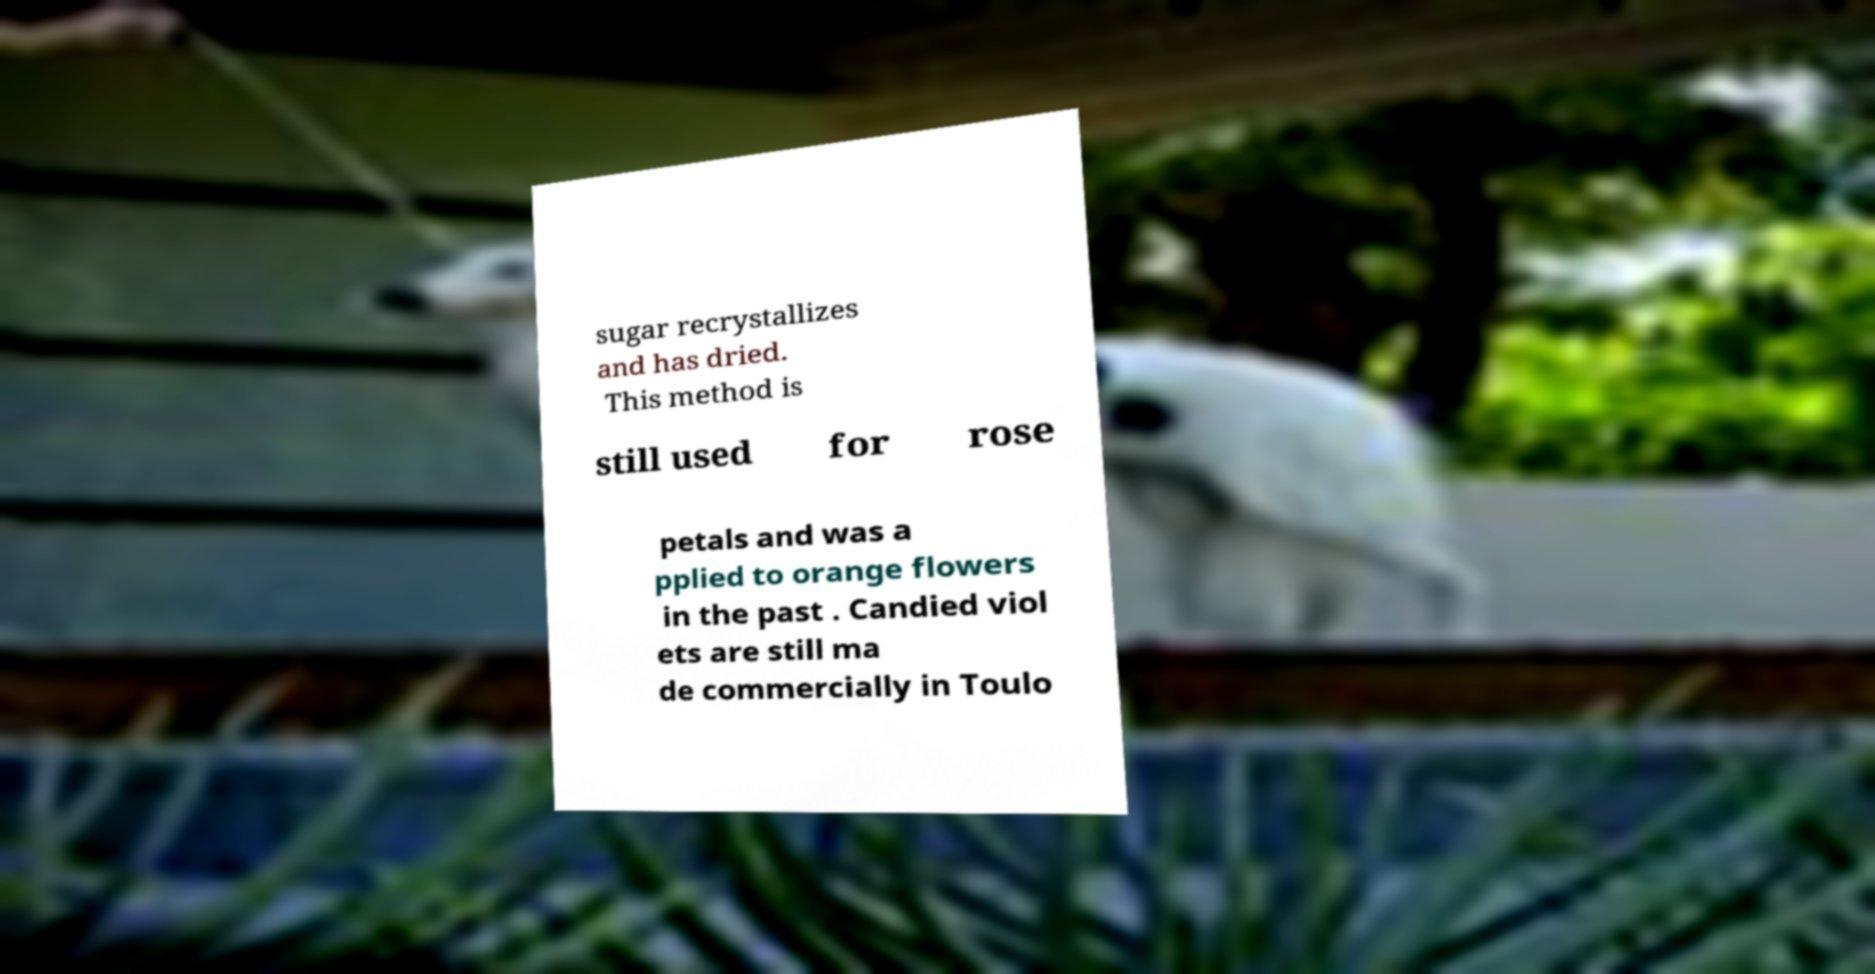Can you accurately transcribe the text from the provided image for me? sugar recrystallizes and has dried. This method is still used for rose petals and was a pplied to orange flowers in the past . Candied viol ets are still ma de commercially in Toulo 